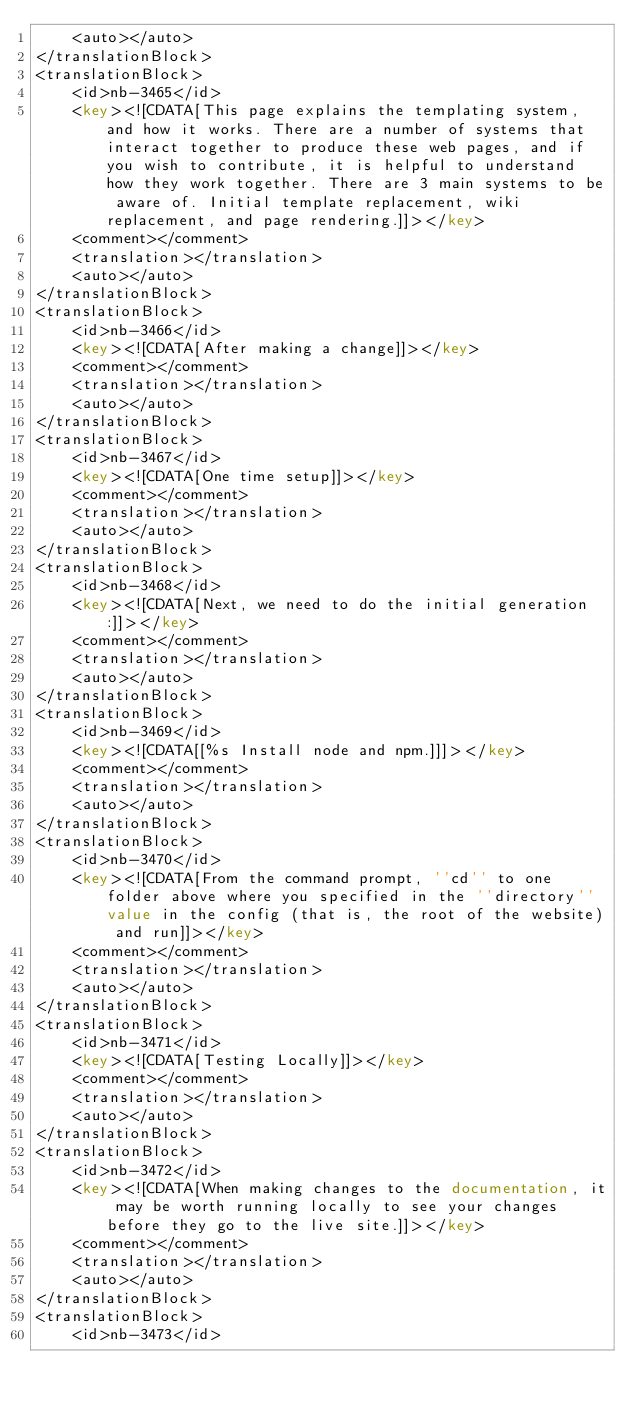Convert code to text. <code><loc_0><loc_0><loc_500><loc_500><_XML_>	<auto></auto>
</translationBlock>
<translationBlock>
	<id>nb-3465</id>
	<key><![CDATA[This page explains the templating system, and how it works. There are a number of systems that interact together to produce these web pages, and if you wish to contribute, it is helpful to understand how they work together. There are 3 main systems to be aware of. Initial template replacement, wiki replacement, and page rendering.]]></key>
	<comment></comment>
	<translation></translation>
	<auto></auto>
</translationBlock>
<translationBlock>
	<id>nb-3466</id>
	<key><![CDATA[After making a change]]></key>
	<comment></comment>
	<translation></translation>
	<auto></auto>
</translationBlock>
<translationBlock>
	<id>nb-3467</id>
	<key><![CDATA[One time setup]]></key>
	<comment></comment>
	<translation></translation>
	<auto></auto>
</translationBlock>
<translationBlock>
	<id>nb-3468</id>
	<key><![CDATA[Next, we need to do the initial generation:]]></key>
	<comment></comment>
	<translation></translation>
	<auto></auto>
</translationBlock>
<translationBlock>
	<id>nb-3469</id>
	<key><![CDATA[[%s Install node and npm.]]]></key>
	<comment></comment>
	<translation></translation>
	<auto></auto>
</translationBlock>
<translationBlock>
	<id>nb-3470</id>
	<key><![CDATA[From the command prompt, ''cd'' to one folder above where you specified in the ''directory'' value in the config (that is, the root of the website) and run]]></key>
	<comment></comment>
	<translation></translation>
	<auto></auto>
</translationBlock>
<translationBlock>
	<id>nb-3471</id>
	<key><![CDATA[Testing Locally]]></key>
	<comment></comment>
	<translation></translation>
	<auto></auto>
</translationBlock>
<translationBlock>
	<id>nb-3472</id>
	<key><![CDATA[When making changes to the documentation, it may be worth running locally to see your changes before they go to the live site.]]></key>
	<comment></comment>
	<translation></translation>
	<auto></auto>
</translationBlock>
<translationBlock>
	<id>nb-3473</id></code> 